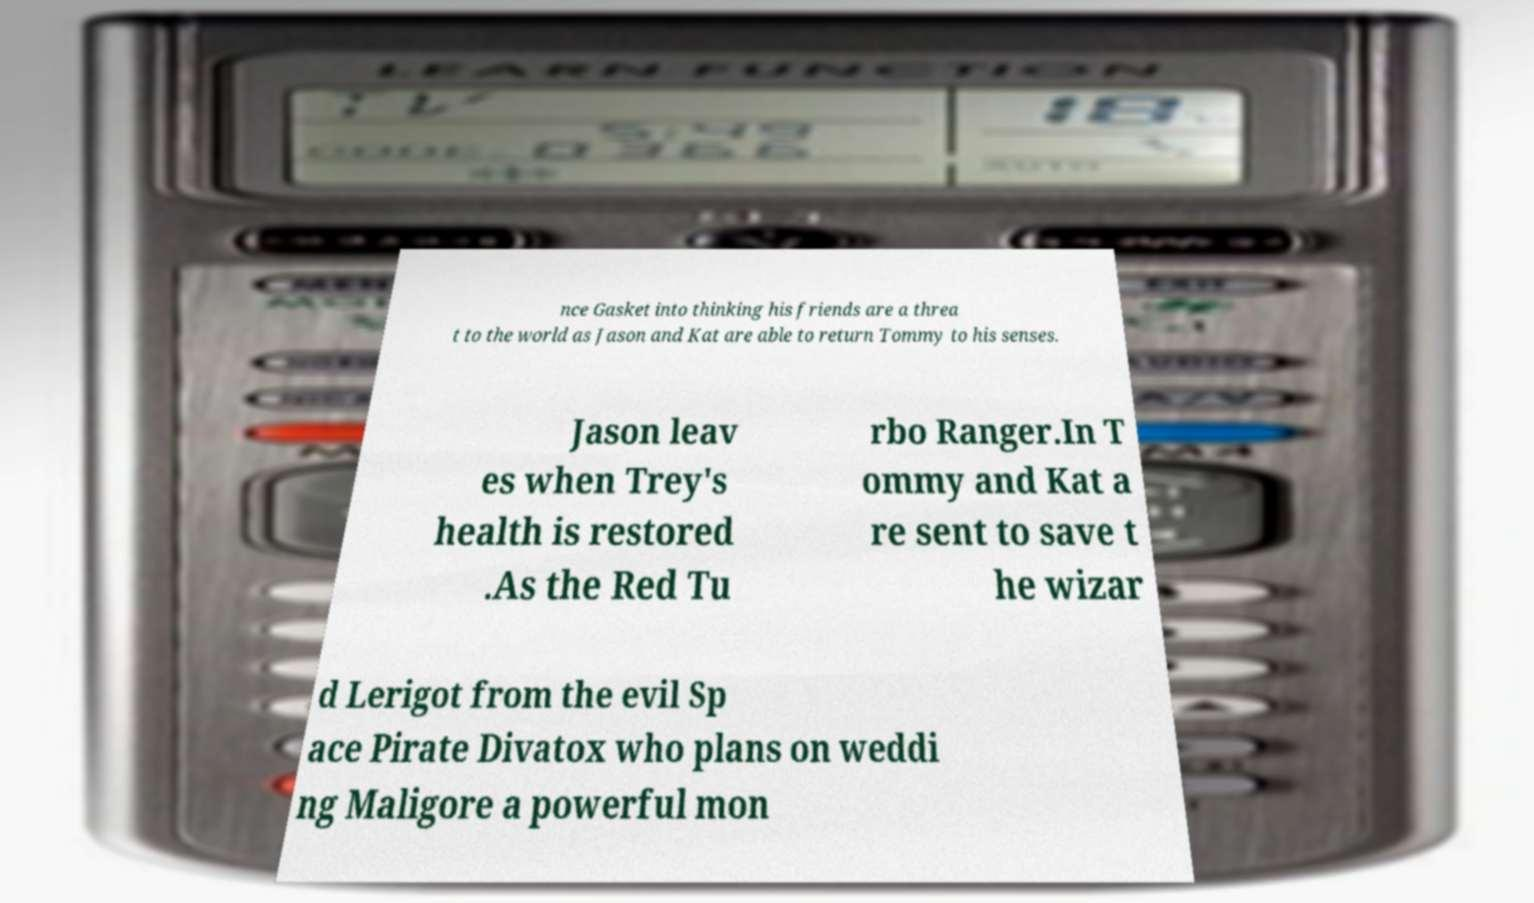For documentation purposes, I need the text within this image transcribed. Could you provide that? nce Gasket into thinking his friends are a threa t to the world as Jason and Kat are able to return Tommy to his senses. Jason leav es when Trey's health is restored .As the Red Tu rbo Ranger.In T ommy and Kat a re sent to save t he wizar d Lerigot from the evil Sp ace Pirate Divatox who plans on weddi ng Maligore a powerful mon 